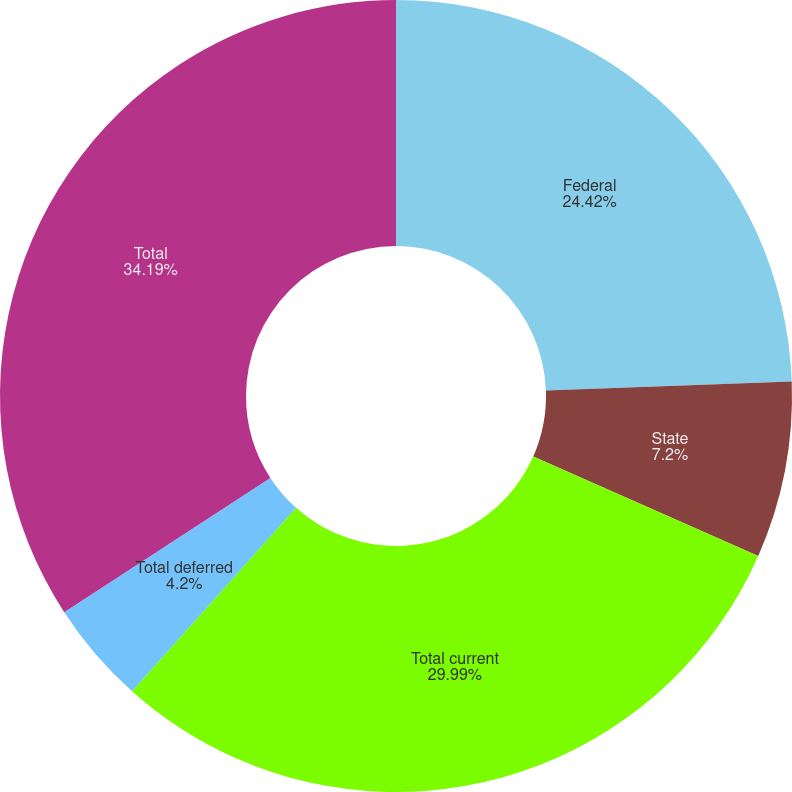Convert chart to OTSL. <chart><loc_0><loc_0><loc_500><loc_500><pie_chart><fcel>Federal<fcel>State<fcel>Total current<fcel>Total deferred<fcel>Total<nl><fcel>24.42%<fcel>7.2%<fcel>29.99%<fcel>4.2%<fcel>34.19%<nl></chart> 